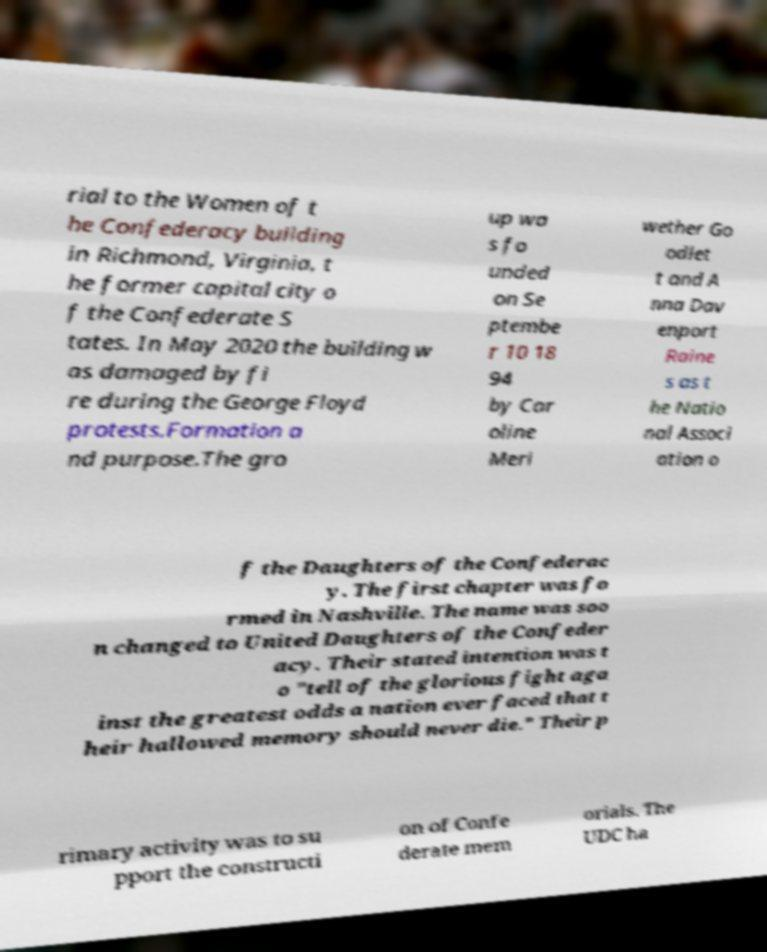Could you assist in decoding the text presented in this image and type it out clearly? rial to the Women of t he Confederacy building in Richmond, Virginia, t he former capital city o f the Confederate S tates. In May 2020 the building w as damaged by fi re during the George Floyd protests.Formation a nd purpose.The gro up wa s fo unded on Se ptembe r 10 18 94 by Car oline Meri wether Go odlet t and A nna Dav enport Raine s as t he Natio nal Associ ation o f the Daughters of the Confederac y. The first chapter was fo rmed in Nashville. The name was soo n changed to United Daughters of the Confeder acy. Their stated intention was t o "tell of the glorious fight aga inst the greatest odds a nation ever faced that t heir hallowed memory should never die." Their p rimary activity was to su pport the constructi on of Confe derate mem orials. The UDC ha 